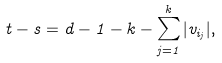Convert formula to latex. <formula><loc_0><loc_0><loc_500><loc_500>t - s = d - 1 - k - \sum _ { j = 1 } ^ { k } | v _ { i _ { j } } | ,</formula> 